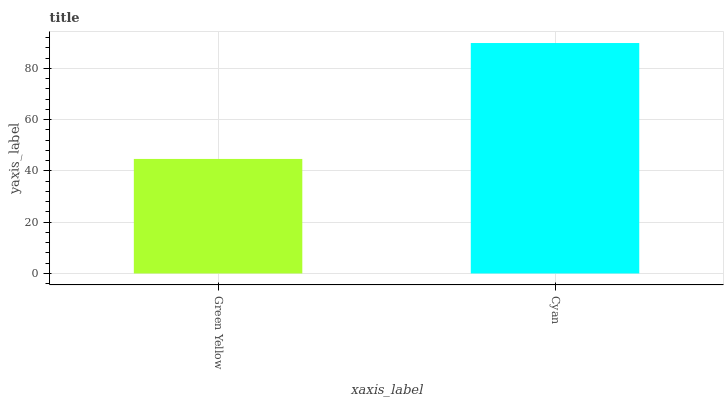Is Cyan the minimum?
Answer yes or no. No. Is Cyan greater than Green Yellow?
Answer yes or no. Yes. Is Green Yellow less than Cyan?
Answer yes or no. Yes. Is Green Yellow greater than Cyan?
Answer yes or no. No. Is Cyan less than Green Yellow?
Answer yes or no. No. Is Cyan the high median?
Answer yes or no. Yes. Is Green Yellow the low median?
Answer yes or no. Yes. Is Green Yellow the high median?
Answer yes or no. No. Is Cyan the low median?
Answer yes or no. No. 